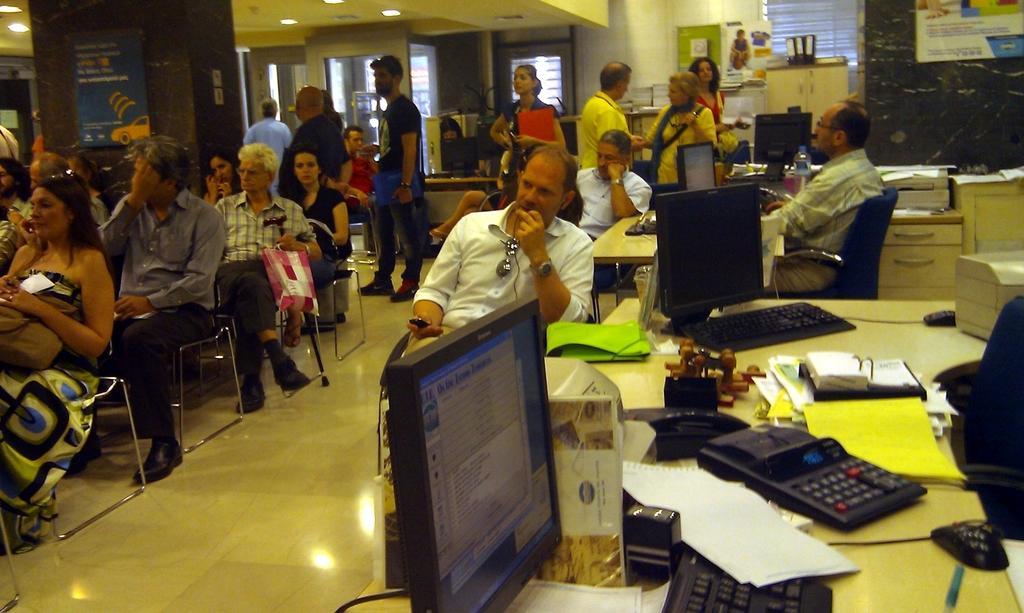In one or two sentences, can you explain what this image depicts? In the picture I can see people among them some are standing on the floor and some are sitting on chairs. I can also see tables which has keyboards, monitors, papers and some other objects. I can also see cupboards, lights on the ceiling, windows, walls and some other objects. 